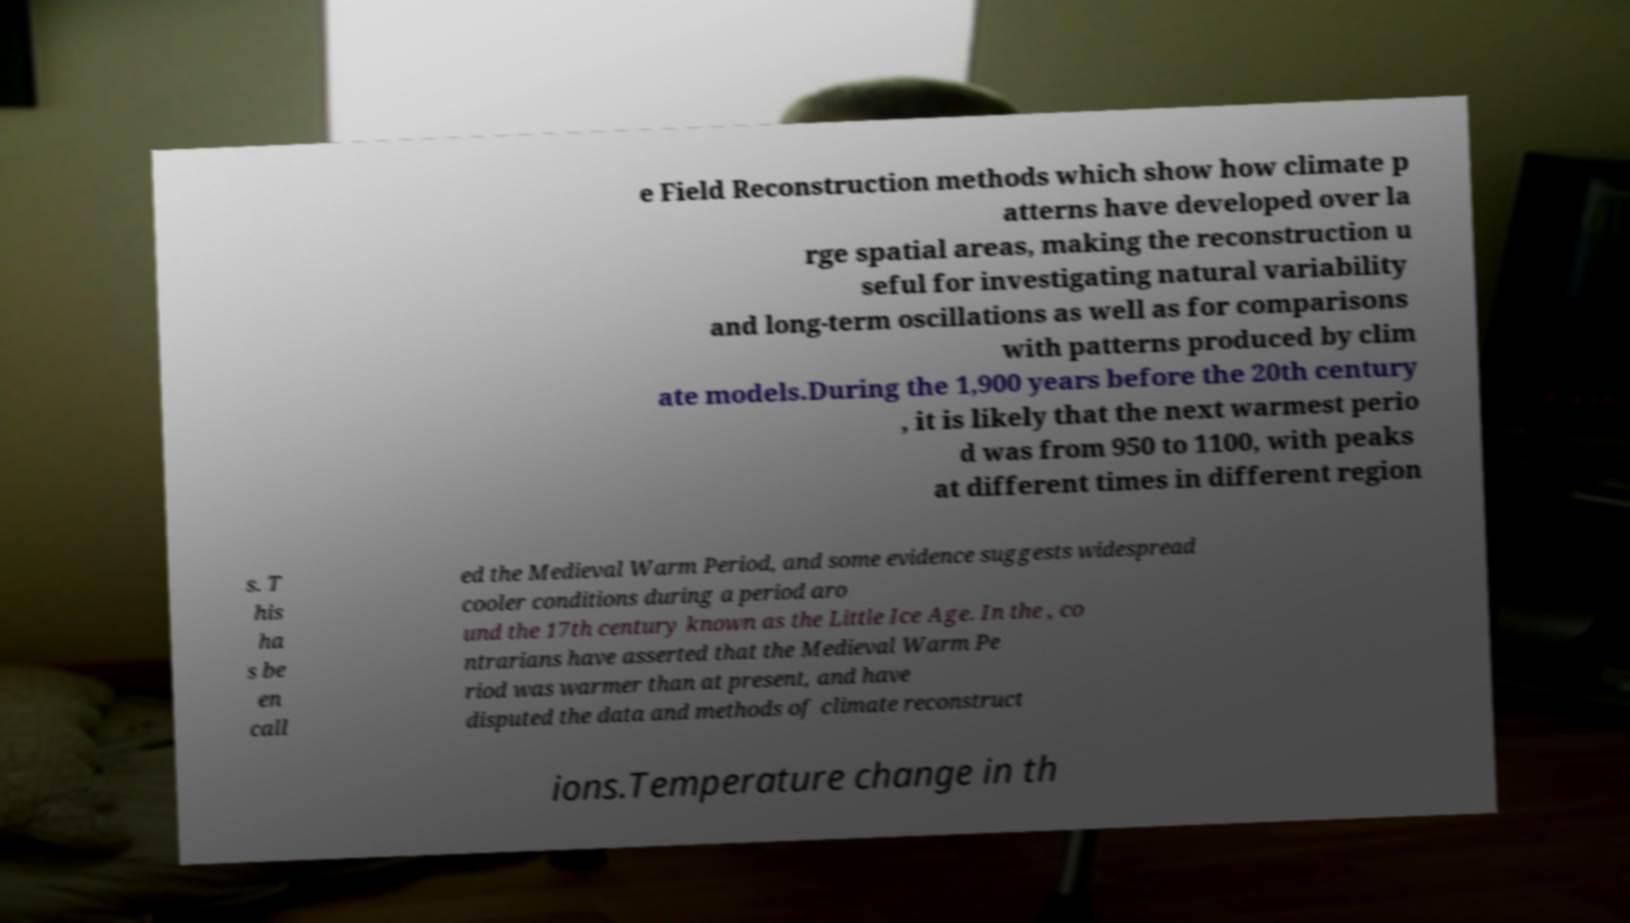Please identify and transcribe the text found in this image. e Field Reconstruction methods which show how climate p atterns have developed over la rge spatial areas, making the reconstruction u seful for investigating natural variability and long-term oscillations as well as for comparisons with patterns produced by clim ate models.During the 1,900 years before the 20th century , it is likely that the next warmest perio d was from 950 to 1100, with peaks at different times in different region s. T his ha s be en call ed the Medieval Warm Period, and some evidence suggests widespread cooler conditions during a period aro und the 17th century known as the Little Ice Age. In the , co ntrarians have asserted that the Medieval Warm Pe riod was warmer than at present, and have disputed the data and methods of climate reconstruct ions.Temperature change in th 